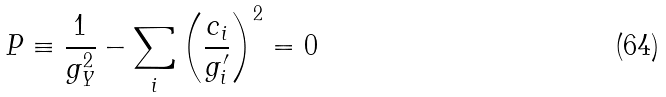<formula> <loc_0><loc_0><loc_500><loc_500>P \equiv \frac { 1 } { g _ { Y } ^ { 2 } } - \sum _ { i } \left ( \frac { c _ { i } } { g ^ { \prime } _ { i } } \right ) ^ { 2 } = 0</formula> 